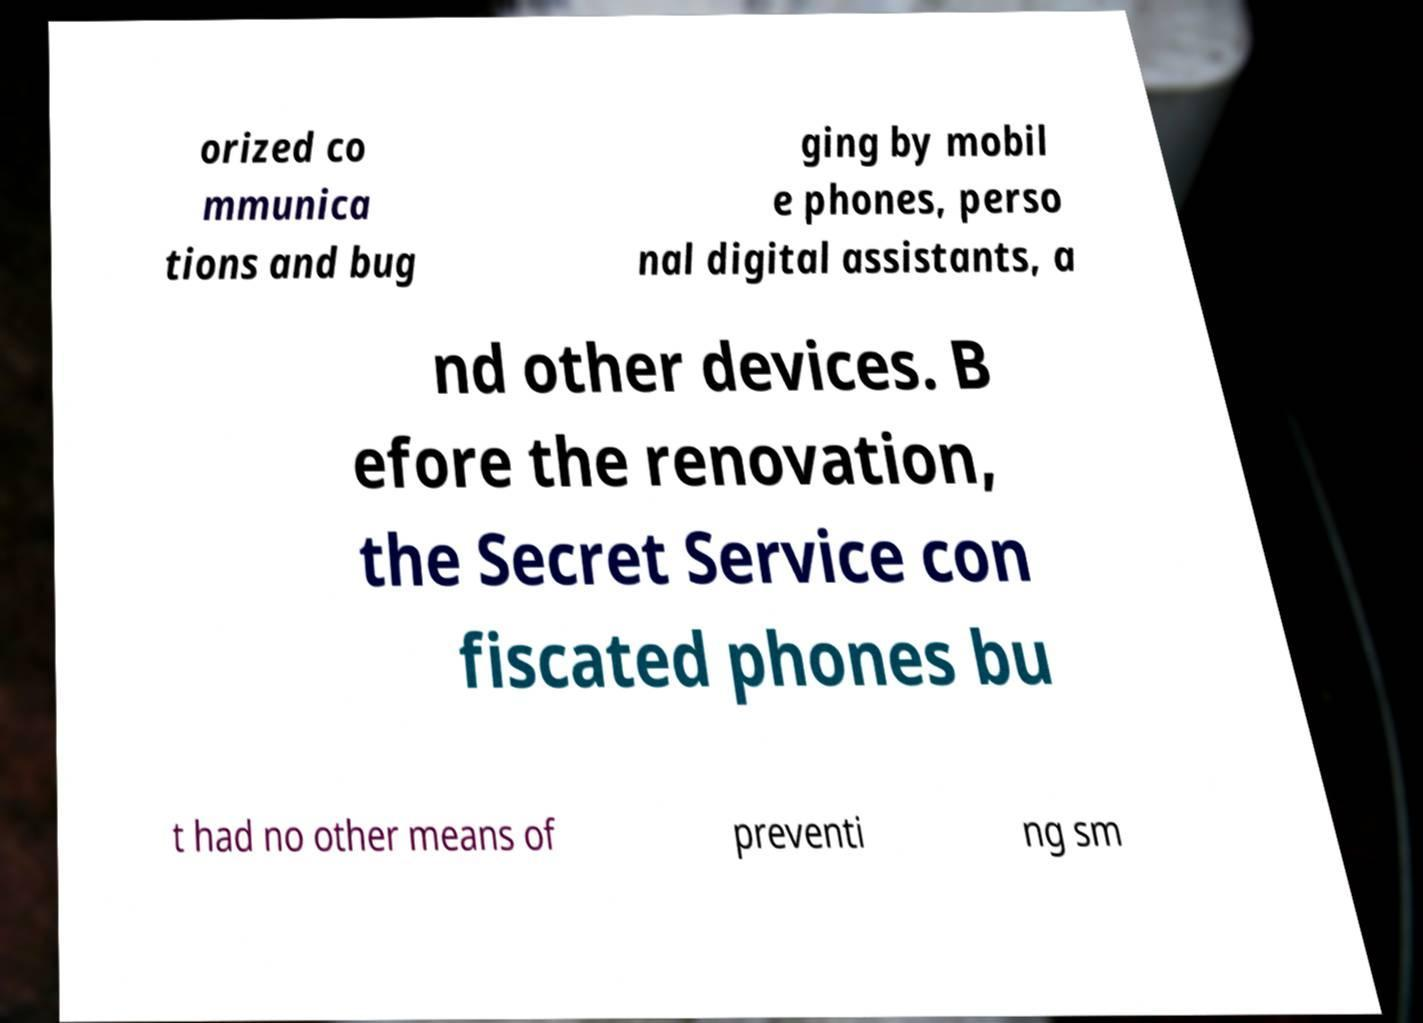What messages or text are displayed in this image? I need them in a readable, typed format. orized co mmunica tions and bug ging by mobil e phones, perso nal digital assistants, a nd other devices. B efore the renovation, the Secret Service con fiscated phones bu t had no other means of preventi ng sm 